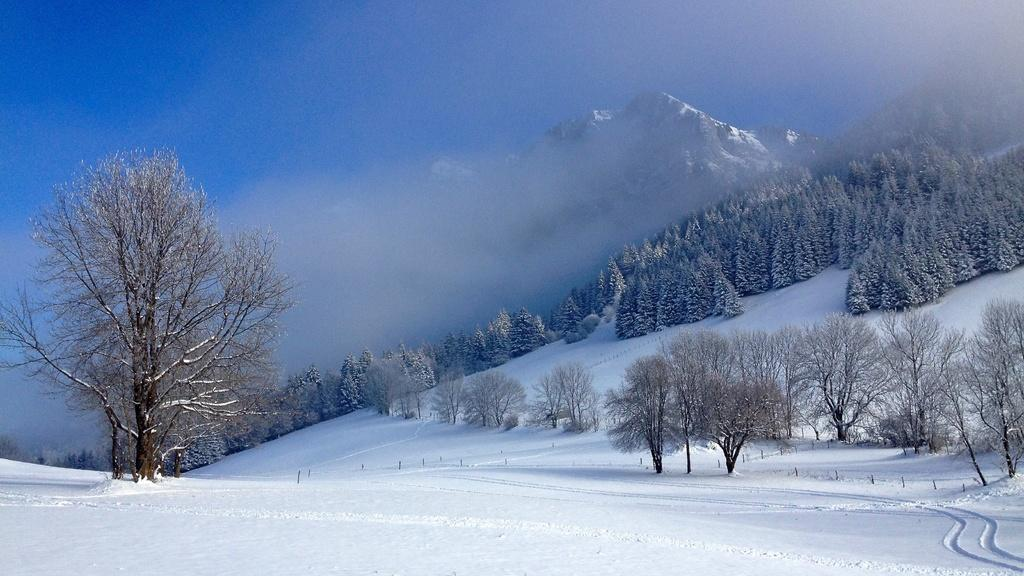What type of weather condition is depicted in the image? There is snow in the image, indicating a cold or wintry weather condition. What natural elements can be seen in the image? There are trees and a hill visible in the image. What atmospheric condition is present in the image? There is fog in the image. What can be seen in the background of the image? The sky is visible in the background of the image. What is the color of the sky in the image? The color of the sky is blue. How many pets are visible in the image? There are no pets present in the image. What type of work is the farmer doing in the image? There is no farmer present in the image. What type of toy is the doll playing with in the image? There is no doll present in the image. 